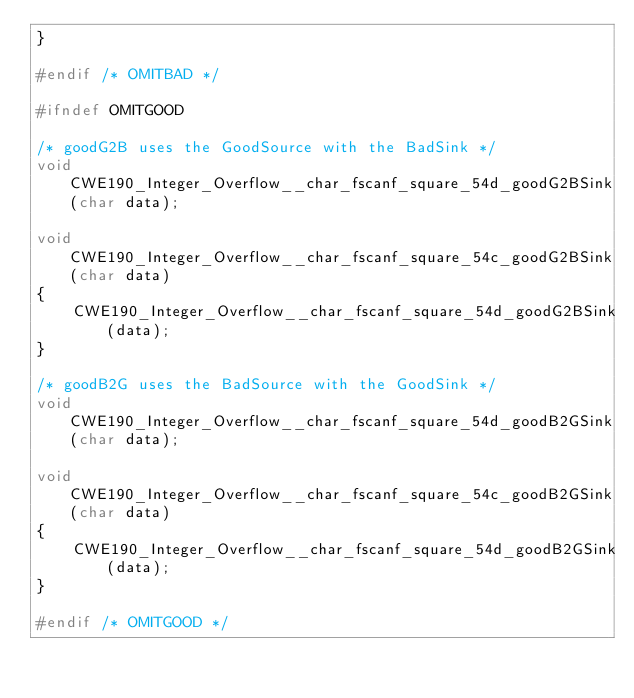Convert code to text. <code><loc_0><loc_0><loc_500><loc_500><_C_>}

#endif /* OMITBAD */

#ifndef OMITGOOD

/* goodG2B uses the GoodSource with the BadSink */
void CWE190_Integer_Overflow__char_fscanf_square_54d_goodG2BSink(char data);

void CWE190_Integer_Overflow__char_fscanf_square_54c_goodG2BSink(char data)
{
    CWE190_Integer_Overflow__char_fscanf_square_54d_goodG2BSink(data);
}

/* goodB2G uses the BadSource with the GoodSink */
void CWE190_Integer_Overflow__char_fscanf_square_54d_goodB2GSink(char data);

void CWE190_Integer_Overflow__char_fscanf_square_54c_goodB2GSink(char data)
{
    CWE190_Integer_Overflow__char_fscanf_square_54d_goodB2GSink(data);
}

#endif /* OMITGOOD */
</code> 